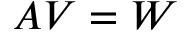Convert formula to latex. <formula><loc_0><loc_0><loc_500><loc_500>A V = W</formula> 